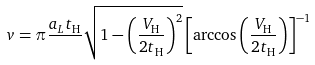Convert formula to latex. <formula><loc_0><loc_0><loc_500><loc_500>v = \pi \frac { a _ { L } t _ { \text {H} } } { } \sqrt { 1 - \left ( \frac { V _ { \text {H} } } { 2 t _ { \text {H} } } \right ) ^ { 2 } } \left [ \arccos \left ( \frac { V _ { \text {H} } } { 2 t _ { \text {H} } } \right ) \right ] ^ { - 1 }</formula> 